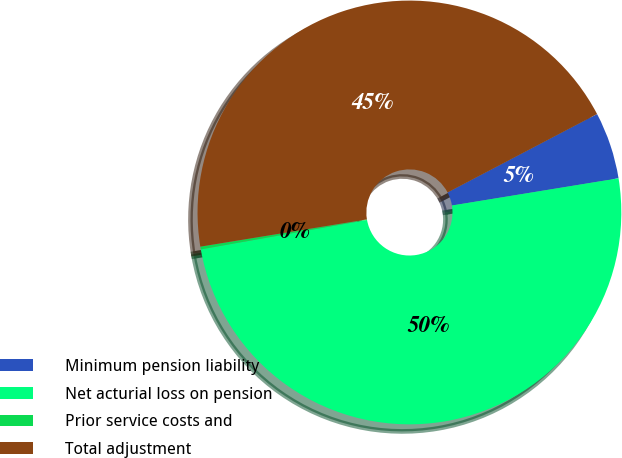Convert chart. <chart><loc_0><loc_0><loc_500><loc_500><pie_chart><fcel>Minimum pension liability<fcel>Net acturial loss on pension<fcel>Prior service costs and<fcel>Total adjustment<nl><fcel>5.11%<fcel>49.79%<fcel>0.21%<fcel>44.89%<nl></chart> 